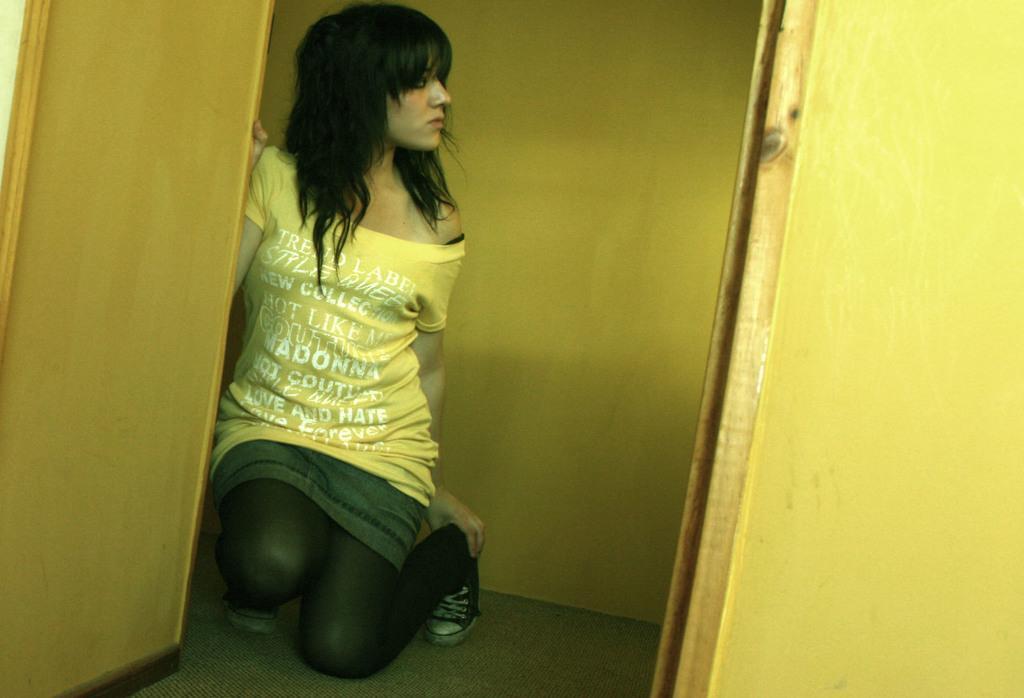Who is the main subject in the image? There is a woman in the image. What is the woman wearing? The woman is wearing a yellow t-shirt. What color are the walls in the image? The walls in the image are yellow. What type of button is the woman using to control the lights in the image? There is no button or mention of lights in the image; it only features a woman wearing a yellow t-shirt in front of yellow walls. 